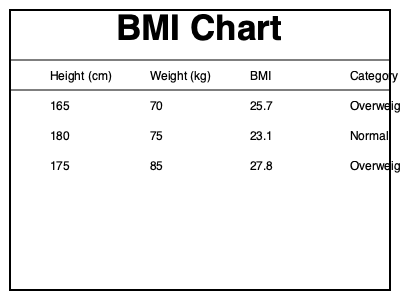As a dietician integrating behavioral psychology into diet plans, you're reviewing a patient's BMI data. Using the BMI chart provided, calculate the BMI for a person who is 175 cm tall and weighs 85 kg. How would you categorize their weight status, and what behavioral approach might you consider in developing their diet plan? To calculate the BMI and determine the weight status:

1. Locate the row in the chart with height 175 cm and weight 85 kg.
2. The BMI for this combination is given as 27.8.
3. The category for this BMI is listed as "Overweight".

To calculate BMI manually:
1. Convert height to meters: 175 cm = 1.75 m
2. Use the BMI formula: $BMI = \frac{weight (kg)}{height (m)^2}$
3. $BMI = \frac{85}{1.75^2} = \frac{85}{3.0625} \approx 27.8$

Behavioral approach consideration:
As a dietician integrating behavioral psychology, you might consider:
1. Assessing the patient's readiness for change using the Transtheoretical Model.
2. Implementing Cognitive Behavioral Therapy techniques to address any negative thought patterns related to diet and weight.
3. Using motivational interviewing to help the patient develop intrinsic motivation for lifestyle changes.
4. Setting SMART (Specific, Measurable, Achievable, Relevant, Time-bound) goals for gradual weight loss.
5. Incorporating mindfulness techniques to promote mindful eating and stress reduction.
Answer: BMI: 27.8, Category: Overweight. Behavioral approach: Assess readiness for change, use CBT techniques, motivational interviewing, set SMART goals, and incorporate mindfulness. 